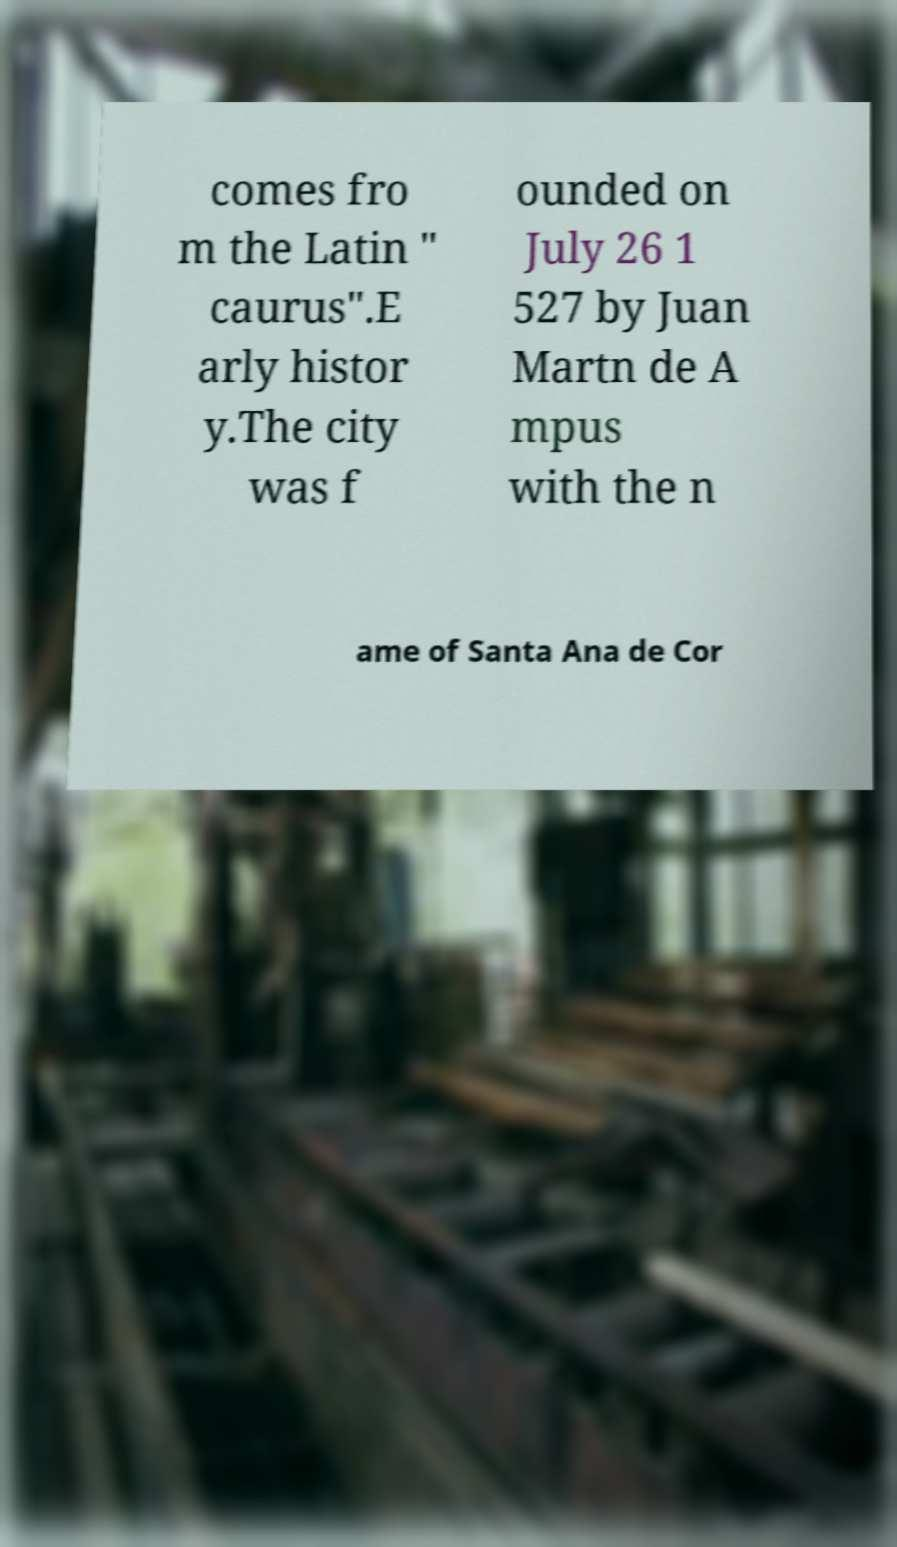Could you extract and type out the text from this image? comes fro m the Latin " caurus".E arly histor y.The city was f ounded on July 26 1 527 by Juan Martn de A mpus with the n ame of Santa Ana de Cor 